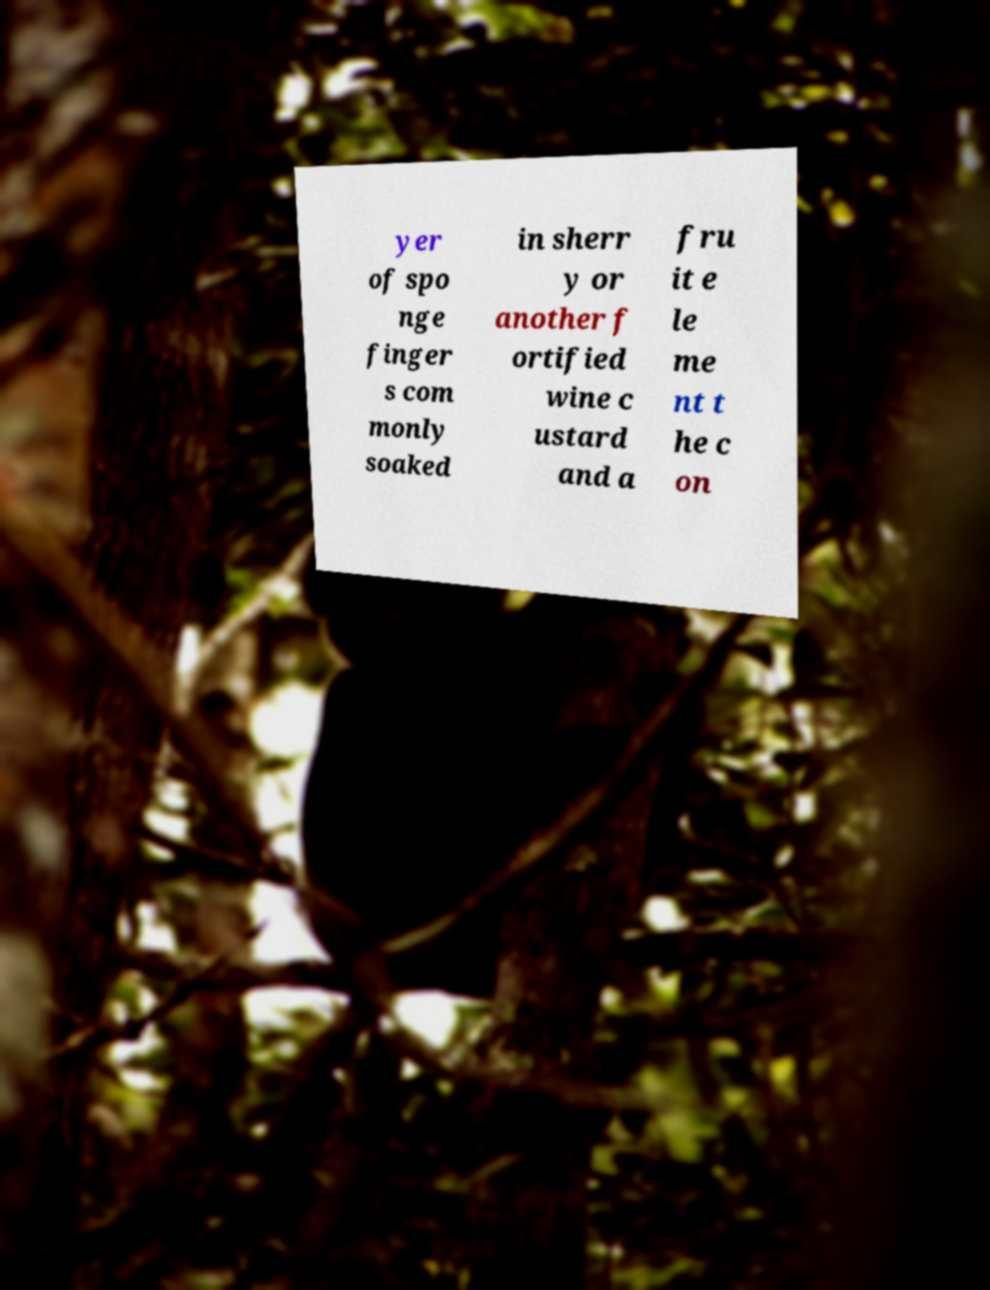Please read and relay the text visible in this image. What does it say? yer of spo nge finger s com monly soaked in sherr y or another f ortified wine c ustard and a fru it e le me nt t he c on 